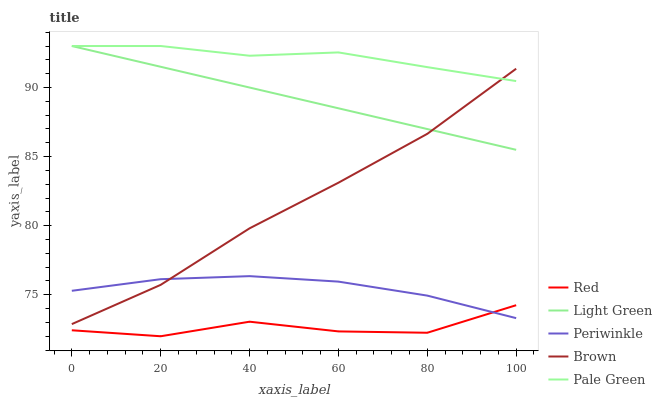Does Red have the minimum area under the curve?
Answer yes or no. Yes. Does Pale Green have the maximum area under the curve?
Answer yes or no. Yes. Does Periwinkle have the minimum area under the curve?
Answer yes or no. No. Does Periwinkle have the maximum area under the curve?
Answer yes or no. No. Is Light Green the smoothest?
Answer yes or no. Yes. Is Red the roughest?
Answer yes or no. Yes. Is Pale Green the smoothest?
Answer yes or no. No. Is Pale Green the roughest?
Answer yes or no. No. Does Red have the lowest value?
Answer yes or no. Yes. Does Periwinkle have the lowest value?
Answer yes or no. No. Does Light Green have the highest value?
Answer yes or no. Yes. Does Periwinkle have the highest value?
Answer yes or no. No. Is Periwinkle less than Pale Green?
Answer yes or no. Yes. Is Pale Green greater than Periwinkle?
Answer yes or no. Yes. Does Light Green intersect Pale Green?
Answer yes or no. Yes. Is Light Green less than Pale Green?
Answer yes or no. No. Is Light Green greater than Pale Green?
Answer yes or no. No. Does Periwinkle intersect Pale Green?
Answer yes or no. No. 